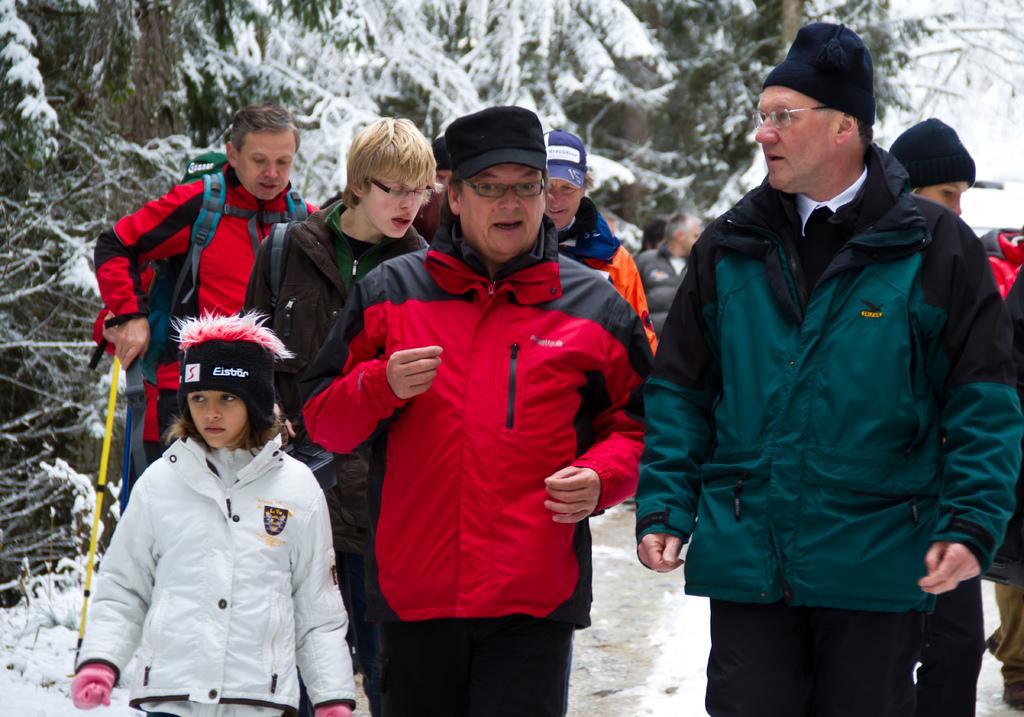Describe this image in one or two sentences. There are many people wearing jacket. On the left side a girl is wearing gloves and a cap. Near to her two persons are wearing cap and specs. In the back some are wearing caps and bags. In the background there are trees with snow. And a person in the back is holding a yellow color stick. 